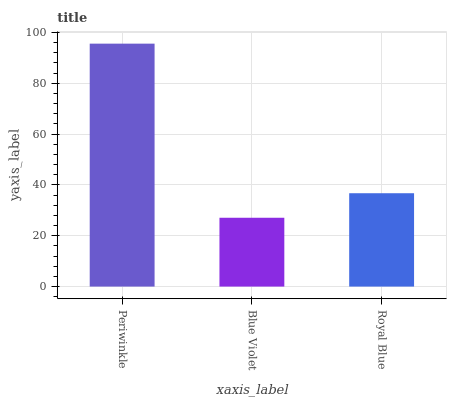Is Blue Violet the minimum?
Answer yes or no. Yes. Is Periwinkle the maximum?
Answer yes or no. Yes. Is Royal Blue the minimum?
Answer yes or no. No. Is Royal Blue the maximum?
Answer yes or no. No. Is Royal Blue greater than Blue Violet?
Answer yes or no. Yes. Is Blue Violet less than Royal Blue?
Answer yes or no. Yes. Is Blue Violet greater than Royal Blue?
Answer yes or no. No. Is Royal Blue less than Blue Violet?
Answer yes or no. No. Is Royal Blue the high median?
Answer yes or no. Yes. Is Royal Blue the low median?
Answer yes or no. Yes. Is Blue Violet the high median?
Answer yes or no. No. Is Blue Violet the low median?
Answer yes or no. No. 